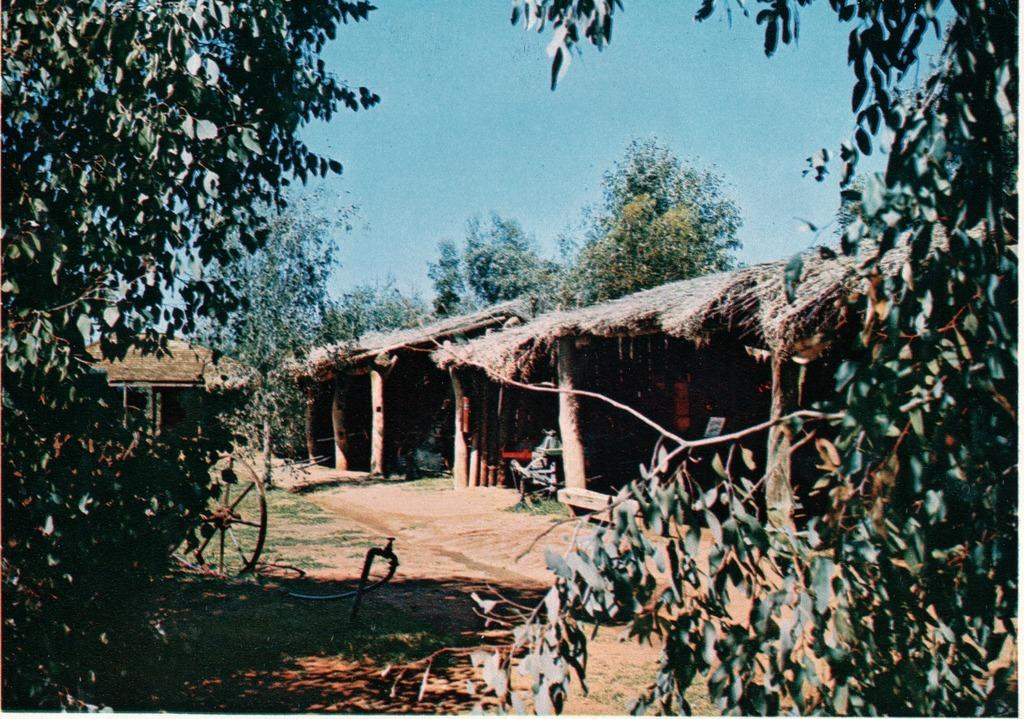What type of structures can be seen on the right side of the image? There are huts on the right side of the image. What type of vegetation is present in the image? There are trees in the image. What type of ground surface is visible in the image? There is grass and sand in the image. What is visible in the background of the image? There is a sky visible in the image. Can you tell me where the bell is located in the image? There is no bell present in the image. Who is the cook in the image? There is no cook present in the image. 